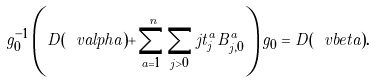Convert formula to latex. <formula><loc_0><loc_0><loc_500><loc_500>g _ { 0 } ^ { - 1 } \left ( D ( \ v a l p h a ) + \sum _ { a = 1 } ^ { n } \sum _ { j > 0 } j t _ { j } ^ { a } B _ { j , 0 } ^ { a } \right ) g _ { 0 } = D ( \ v b e t a ) .</formula> 